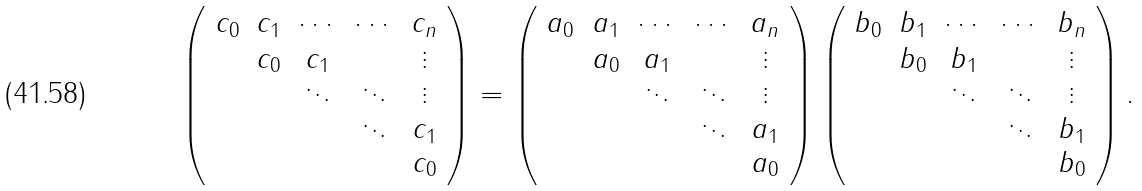Convert formula to latex. <formula><loc_0><loc_0><loc_500><loc_500>\left ( \begin{array} { c c c c c } c _ { 0 } & c _ { 1 } & \cdots & \cdots & c _ { n } \\ & c _ { 0 } & c _ { 1 } & & \vdots \\ & & \ddots & \ddots & \vdots \\ & & & \ddots & c _ { 1 } \\ & & & & c _ { 0 } \end{array} \right ) = \left ( \begin{array} { c c c c c } a _ { 0 } & a _ { 1 } & \cdots & \cdots & a _ { n } \\ & a _ { 0 } & a _ { 1 } & & \vdots \\ & & \ddots & \ddots & \vdots \\ & & & \ddots & a _ { 1 } \\ & & & & a _ { 0 } \end{array} \right ) \left ( \begin{array} { c c c c c } b _ { 0 } & b _ { 1 } & \cdots & \cdots & b _ { n } \\ & b _ { 0 } & b _ { 1 } & & \vdots \\ & & \ddots & \ddots & \vdots \\ & & & \ddots & b _ { 1 } \\ & & & & b _ { 0 } \end{array} \right ) .</formula> 